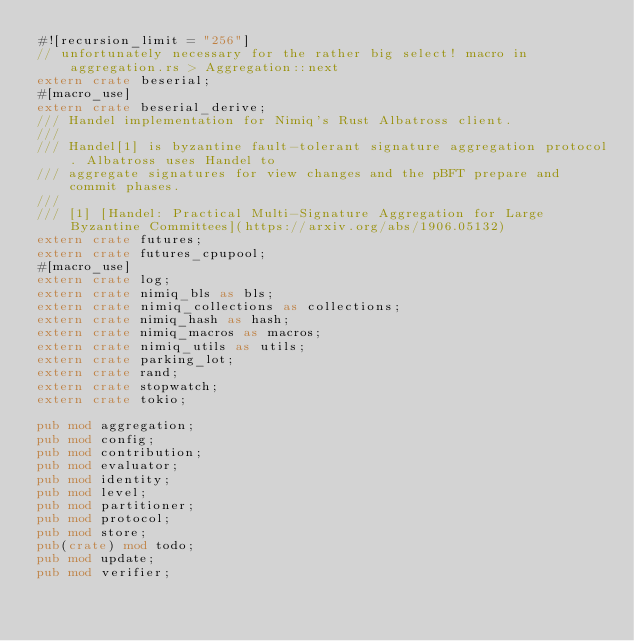Convert code to text. <code><loc_0><loc_0><loc_500><loc_500><_Rust_>#![recursion_limit = "256"]
// unfortunately necessary for the rather big select! macro in aggregation.rs > Aggregation::next
extern crate beserial;
#[macro_use]
extern crate beserial_derive;
/// Handel implementation for Nimiq's Rust Albatross client.
///
/// Handel[1] is byzantine fault-tolerant signature aggregation protocol. Albatross uses Handel to
/// aggregate signatures for view changes and the pBFT prepare and commit phases.
///
/// [1] [Handel: Practical Multi-Signature Aggregation for Large Byzantine Committees](https://arxiv.org/abs/1906.05132)
extern crate futures;
extern crate futures_cpupool;
#[macro_use]
extern crate log;
extern crate nimiq_bls as bls;
extern crate nimiq_collections as collections;
extern crate nimiq_hash as hash;
extern crate nimiq_macros as macros;
extern crate nimiq_utils as utils;
extern crate parking_lot;
extern crate rand;
extern crate stopwatch;
extern crate tokio;

pub mod aggregation;
pub mod config;
pub mod contribution;
pub mod evaluator;
pub mod identity;
pub mod level;
pub mod partitioner;
pub mod protocol;
pub mod store;
pub(crate) mod todo;
pub mod update;
pub mod verifier;
</code> 